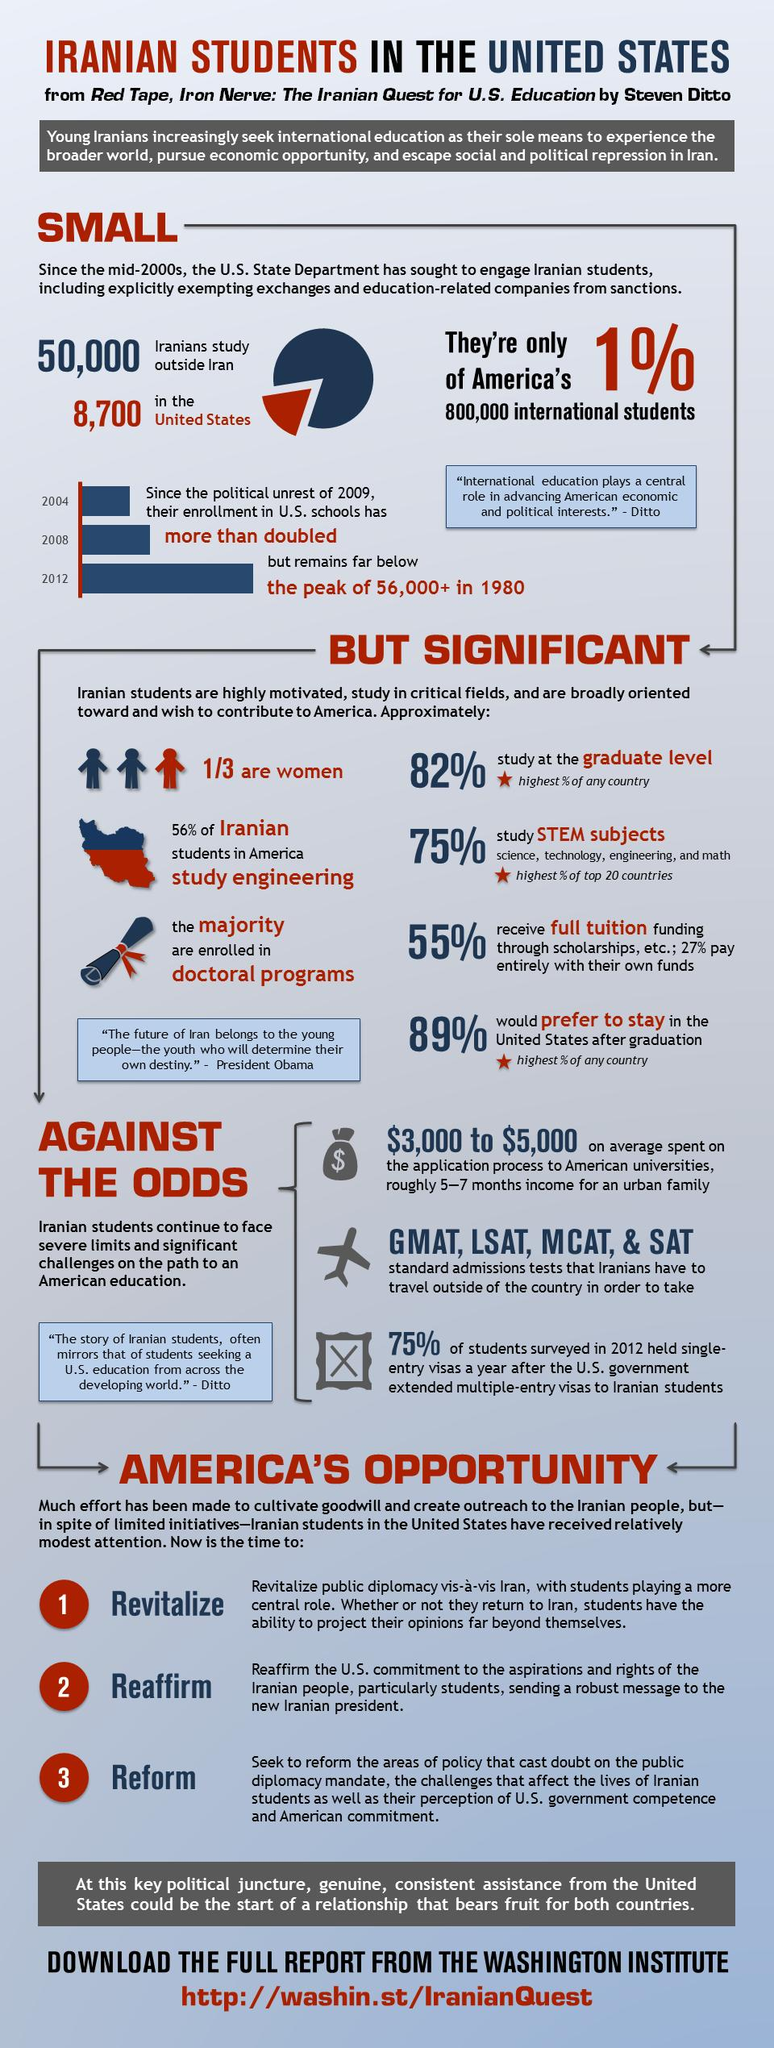Specify some key components in this picture. According to recent data, 82% of Iranian students are currently studying at the graduate level. The average amount of money spent by Iranian students on the application process to American universities is between $3,000 and $5,000. According to a recent survey, 11% of Iranian students do not prefer to stay in the United States after graduation. In Iran, it is reported that 75% of students study STEM subjects. There are approximately 50,000 Iranians currently studying outside of Iran. 